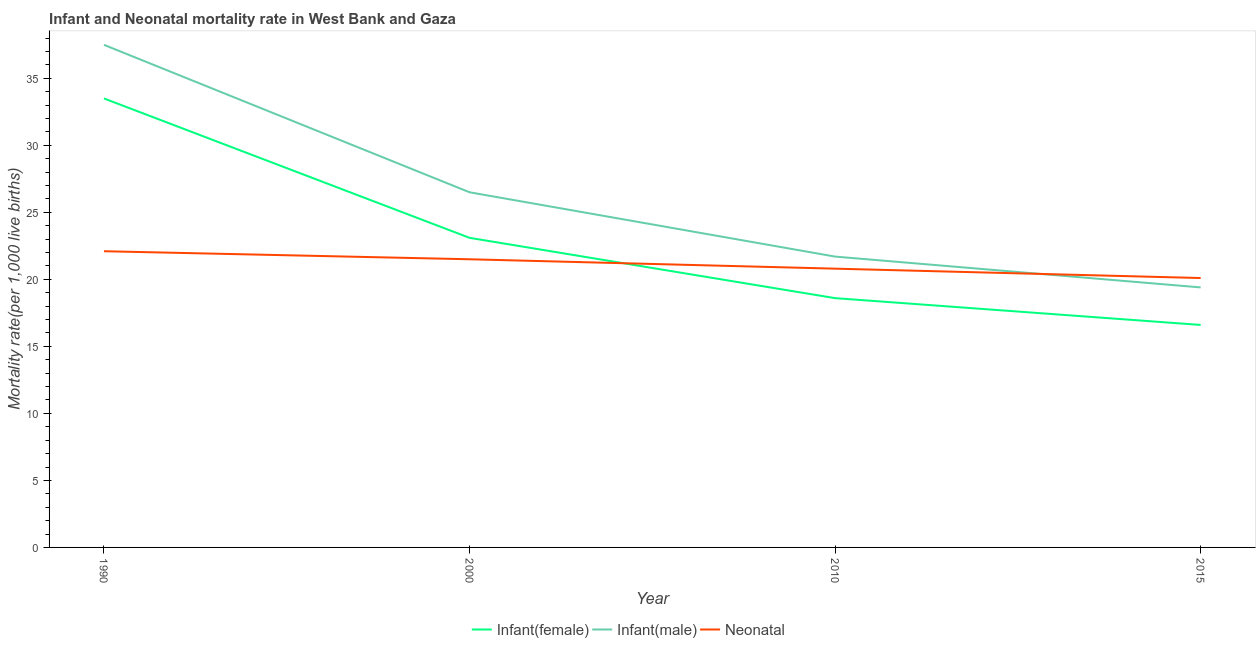Is the number of lines equal to the number of legend labels?
Your answer should be very brief. Yes. What is the neonatal mortality rate in 1990?
Make the answer very short. 22.1. Across all years, what is the maximum neonatal mortality rate?
Offer a terse response. 22.1. Across all years, what is the minimum infant mortality rate(male)?
Provide a short and direct response. 19.4. In which year was the infant mortality rate(male) minimum?
Make the answer very short. 2015. What is the total infant mortality rate(female) in the graph?
Provide a short and direct response. 91.8. What is the difference between the neonatal mortality rate in 2015 and the infant mortality rate(male) in 2000?
Give a very brief answer. -6.4. What is the average neonatal mortality rate per year?
Offer a terse response. 21.12. In the year 2010, what is the difference between the infant mortality rate(female) and infant mortality rate(male)?
Provide a short and direct response. -3.1. In how many years, is the neonatal mortality rate greater than 37?
Make the answer very short. 0. What is the ratio of the infant mortality rate(female) in 1990 to that in 2015?
Make the answer very short. 2.02. Is the infant mortality rate(male) in 1990 less than that in 2015?
Offer a very short reply. No. What is the difference between the highest and the second highest neonatal mortality rate?
Provide a succinct answer. 0.6. In how many years, is the infant mortality rate(male) greater than the average infant mortality rate(male) taken over all years?
Provide a short and direct response. 2. Does the infant mortality rate(female) monotonically increase over the years?
Offer a very short reply. No. Is the neonatal mortality rate strictly greater than the infant mortality rate(male) over the years?
Make the answer very short. No. Is the neonatal mortality rate strictly less than the infant mortality rate(female) over the years?
Offer a very short reply. No. How many lines are there?
Provide a short and direct response. 3. Does the graph contain any zero values?
Make the answer very short. No. Where does the legend appear in the graph?
Offer a very short reply. Bottom center. How are the legend labels stacked?
Offer a terse response. Horizontal. What is the title of the graph?
Keep it short and to the point. Infant and Neonatal mortality rate in West Bank and Gaza. Does "Agricultural raw materials" appear as one of the legend labels in the graph?
Give a very brief answer. No. What is the label or title of the X-axis?
Ensure brevity in your answer.  Year. What is the label or title of the Y-axis?
Your answer should be very brief. Mortality rate(per 1,0 live births). What is the Mortality rate(per 1,000 live births) in Infant(female) in 1990?
Your response must be concise. 33.5. What is the Mortality rate(per 1,000 live births) of Infant(male) in 1990?
Offer a terse response. 37.5. What is the Mortality rate(per 1,000 live births) in Neonatal  in 1990?
Offer a very short reply. 22.1. What is the Mortality rate(per 1,000 live births) in Infant(female) in 2000?
Keep it short and to the point. 23.1. What is the Mortality rate(per 1,000 live births) of Neonatal  in 2000?
Your answer should be compact. 21.5. What is the Mortality rate(per 1,000 live births) of Infant(female) in 2010?
Offer a very short reply. 18.6. What is the Mortality rate(per 1,000 live births) in Infant(male) in 2010?
Offer a terse response. 21.7. What is the Mortality rate(per 1,000 live births) of Neonatal  in 2010?
Your answer should be compact. 20.8. What is the Mortality rate(per 1,000 live births) of Neonatal  in 2015?
Offer a terse response. 20.1. Across all years, what is the maximum Mortality rate(per 1,000 live births) of Infant(female)?
Offer a terse response. 33.5. Across all years, what is the maximum Mortality rate(per 1,000 live births) of Infant(male)?
Make the answer very short. 37.5. Across all years, what is the maximum Mortality rate(per 1,000 live births) in Neonatal ?
Your response must be concise. 22.1. Across all years, what is the minimum Mortality rate(per 1,000 live births) of Infant(female)?
Provide a succinct answer. 16.6. Across all years, what is the minimum Mortality rate(per 1,000 live births) in Neonatal ?
Ensure brevity in your answer.  20.1. What is the total Mortality rate(per 1,000 live births) of Infant(female) in the graph?
Provide a short and direct response. 91.8. What is the total Mortality rate(per 1,000 live births) of Infant(male) in the graph?
Offer a terse response. 105.1. What is the total Mortality rate(per 1,000 live births) of Neonatal  in the graph?
Your answer should be compact. 84.5. What is the difference between the Mortality rate(per 1,000 live births) in Infant(female) in 1990 and that in 2010?
Offer a terse response. 14.9. What is the difference between the Mortality rate(per 1,000 live births) in Infant(male) in 1990 and that in 2010?
Your answer should be compact. 15.8. What is the difference between the Mortality rate(per 1,000 live births) of Neonatal  in 1990 and that in 2010?
Your response must be concise. 1.3. What is the difference between the Mortality rate(per 1,000 live births) of Neonatal  in 1990 and that in 2015?
Your answer should be very brief. 2. What is the difference between the Mortality rate(per 1,000 live births) in Infant(female) in 2000 and that in 2010?
Your response must be concise. 4.5. What is the difference between the Mortality rate(per 1,000 live births) in Neonatal  in 2000 and that in 2010?
Give a very brief answer. 0.7. What is the difference between the Mortality rate(per 1,000 live births) of Infant(female) in 2000 and that in 2015?
Make the answer very short. 6.5. What is the difference between the Mortality rate(per 1,000 live births) of Infant(male) in 2000 and that in 2015?
Make the answer very short. 7.1. What is the difference between the Mortality rate(per 1,000 live births) of Infant(female) in 2010 and that in 2015?
Make the answer very short. 2. What is the difference between the Mortality rate(per 1,000 live births) of Infant(male) in 2010 and that in 2015?
Keep it short and to the point. 2.3. What is the difference between the Mortality rate(per 1,000 live births) in Neonatal  in 2010 and that in 2015?
Your answer should be compact. 0.7. What is the difference between the Mortality rate(per 1,000 live births) in Infant(male) in 1990 and the Mortality rate(per 1,000 live births) in Neonatal  in 2000?
Make the answer very short. 16. What is the difference between the Mortality rate(per 1,000 live births) of Infant(female) in 1990 and the Mortality rate(per 1,000 live births) of Infant(male) in 2010?
Ensure brevity in your answer.  11.8. What is the difference between the Mortality rate(per 1,000 live births) in Infant(female) in 1990 and the Mortality rate(per 1,000 live births) in Neonatal  in 2010?
Give a very brief answer. 12.7. What is the difference between the Mortality rate(per 1,000 live births) in Infant(male) in 1990 and the Mortality rate(per 1,000 live births) in Neonatal  in 2010?
Keep it short and to the point. 16.7. What is the difference between the Mortality rate(per 1,000 live births) of Infant(female) in 1990 and the Mortality rate(per 1,000 live births) of Infant(male) in 2015?
Provide a short and direct response. 14.1. What is the difference between the Mortality rate(per 1,000 live births) of Infant(female) in 1990 and the Mortality rate(per 1,000 live births) of Neonatal  in 2015?
Ensure brevity in your answer.  13.4. What is the difference between the Mortality rate(per 1,000 live births) of Infant(female) in 2000 and the Mortality rate(per 1,000 live births) of Infant(male) in 2010?
Make the answer very short. 1.4. What is the difference between the Mortality rate(per 1,000 live births) of Infant(female) in 2010 and the Mortality rate(per 1,000 live births) of Infant(male) in 2015?
Provide a short and direct response. -0.8. What is the difference between the Mortality rate(per 1,000 live births) of Infant(female) in 2010 and the Mortality rate(per 1,000 live births) of Neonatal  in 2015?
Ensure brevity in your answer.  -1.5. What is the difference between the Mortality rate(per 1,000 live births) in Infant(male) in 2010 and the Mortality rate(per 1,000 live births) in Neonatal  in 2015?
Offer a terse response. 1.6. What is the average Mortality rate(per 1,000 live births) in Infant(female) per year?
Keep it short and to the point. 22.95. What is the average Mortality rate(per 1,000 live births) of Infant(male) per year?
Offer a terse response. 26.27. What is the average Mortality rate(per 1,000 live births) of Neonatal  per year?
Provide a short and direct response. 21.12. In the year 2000, what is the difference between the Mortality rate(per 1,000 live births) in Infant(female) and Mortality rate(per 1,000 live births) in Neonatal ?
Your response must be concise. 1.6. In the year 2000, what is the difference between the Mortality rate(per 1,000 live births) of Infant(male) and Mortality rate(per 1,000 live births) of Neonatal ?
Offer a terse response. 5. In the year 2010, what is the difference between the Mortality rate(per 1,000 live births) of Infant(female) and Mortality rate(per 1,000 live births) of Infant(male)?
Your answer should be very brief. -3.1. In the year 2010, what is the difference between the Mortality rate(per 1,000 live births) in Infant(female) and Mortality rate(per 1,000 live births) in Neonatal ?
Offer a terse response. -2.2. In the year 2015, what is the difference between the Mortality rate(per 1,000 live births) in Infant(female) and Mortality rate(per 1,000 live births) in Neonatal ?
Your response must be concise. -3.5. What is the ratio of the Mortality rate(per 1,000 live births) in Infant(female) in 1990 to that in 2000?
Your answer should be very brief. 1.45. What is the ratio of the Mortality rate(per 1,000 live births) in Infant(male) in 1990 to that in 2000?
Keep it short and to the point. 1.42. What is the ratio of the Mortality rate(per 1,000 live births) in Neonatal  in 1990 to that in 2000?
Offer a terse response. 1.03. What is the ratio of the Mortality rate(per 1,000 live births) in Infant(female) in 1990 to that in 2010?
Provide a short and direct response. 1.8. What is the ratio of the Mortality rate(per 1,000 live births) of Infant(male) in 1990 to that in 2010?
Offer a very short reply. 1.73. What is the ratio of the Mortality rate(per 1,000 live births) in Neonatal  in 1990 to that in 2010?
Your answer should be very brief. 1.06. What is the ratio of the Mortality rate(per 1,000 live births) of Infant(female) in 1990 to that in 2015?
Make the answer very short. 2.02. What is the ratio of the Mortality rate(per 1,000 live births) in Infant(male) in 1990 to that in 2015?
Provide a succinct answer. 1.93. What is the ratio of the Mortality rate(per 1,000 live births) of Neonatal  in 1990 to that in 2015?
Offer a very short reply. 1.1. What is the ratio of the Mortality rate(per 1,000 live births) of Infant(female) in 2000 to that in 2010?
Offer a very short reply. 1.24. What is the ratio of the Mortality rate(per 1,000 live births) in Infant(male) in 2000 to that in 2010?
Give a very brief answer. 1.22. What is the ratio of the Mortality rate(per 1,000 live births) in Neonatal  in 2000 to that in 2010?
Your response must be concise. 1.03. What is the ratio of the Mortality rate(per 1,000 live births) in Infant(female) in 2000 to that in 2015?
Ensure brevity in your answer.  1.39. What is the ratio of the Mortality rate(per 1,000 live births) of Infant(male) in 2000 to that in 2015?
Your answer should be compact. 1.37. What is the ratio of the Mortality rate(per 1,000 live births) of Neonatal  in 2000 to that in 2015?
Your response must be concise. 1.07. What is the ratio of the Mortality rate(per 1,000 live births) of Infant(female) in 2010 to that in 2015?
Your answer should be compact. 1.12. What is the ratio of the Mortality rate(per 1,000 live births) in Infant(male) in 2010 to that in 2015?
Ensure brevity in your answer.  1.12. What is the ratio of the Mortality rate(per 1,000 live births) in Neonatal  in 2010 to that in 2015?
Provide a short and direct response. 1.03. What is the difference between the highest and the lowest Mortality rate(per 1,000 live births) in Infant(female)?
Provide a short and direct response. 16.9. What is the difference between the highest and the lowest Mortality rate(per 1,000 live births) of Neonatal ?
Keep it short and to the point. 2. 